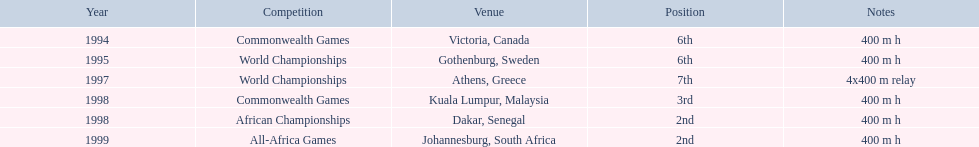In which country did the 1997 championships take place? Athens, Greece. What was the length of the relay? 4x400 m relay. 